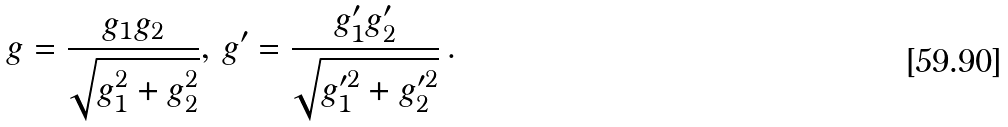Convert formula to latex. <formula><loc_0><loc_0><loc_500><loc_500>g = \frac { g _ { 1 } g _ { 2 } } { \sqrt { g _ { 1 } ^ { 2 } + g _ { 2 } ^ { 2 } } } , \, g ^ { \prime } = \frac { g _ { 1 } ^ { \prime } g _ { 2 } ^ { \prime } } { \sqrt { g _ { 1 } ^ { \prime 2 } + g _ { 2 } ^ { \prime 2 } } } \, .</formula> 